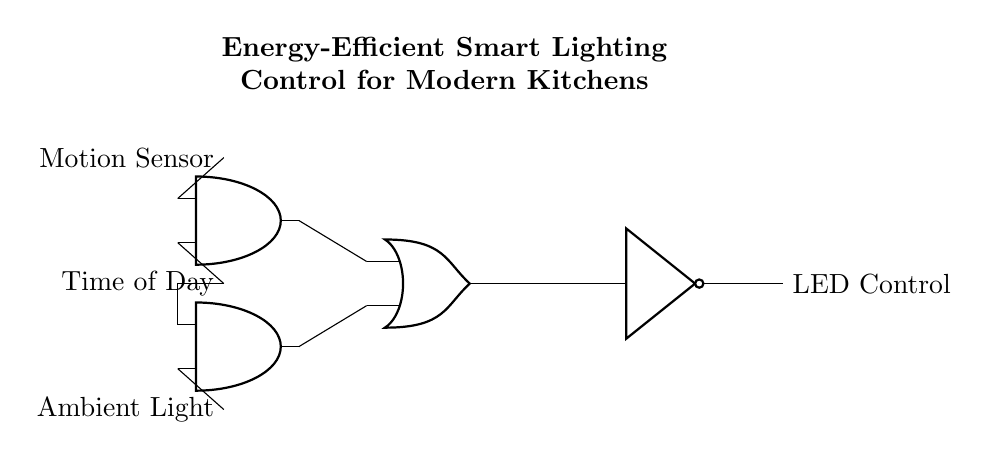What is the main output of the circuit? The main output of the circuit is the LED Control, which is what activates the lighting in response to the conditions set by the inputs.
Answer: LED Control How many AND gates are in the circuit? There are two AND gates in the circuit, which are designed to combine inputs from the motion sensor, time of day, and ambient light to determine if the LED should be turned on.
Answer: 2 What does the NOT gate do in this circuit? The NOT gate inverts the output from the OR gate. If the OR gate outputs a high signal, the NOT gate will output a low signal, effectively controlling the LED by turning it off.
Answer: Inverts output What two inputs are combined in the second AND gate? The second AND gate combines the Ambient Light input and the Time of Day input, allowing the system to consider both factors when determining whether to activate the LED.
Answer: Ambient Light and Time of Day What logic function does the OR gate perform in this design? The OR gate combines the outputs from both AND gates, meaning if either of the AND gates outputs a high signal, the OR gate will also output a high signal, indicating that the LED should be controlled.
Answer: OR function If the motion sensor and the time of day both indicate active conditions, what will happen? If both the motion sensor and time of day inputs to the first AND gate are active, that gate will output high, subsequently activating the OR gate, which would signal the NOT gate to control the LED accordingly.
Answer: LED may turn on 